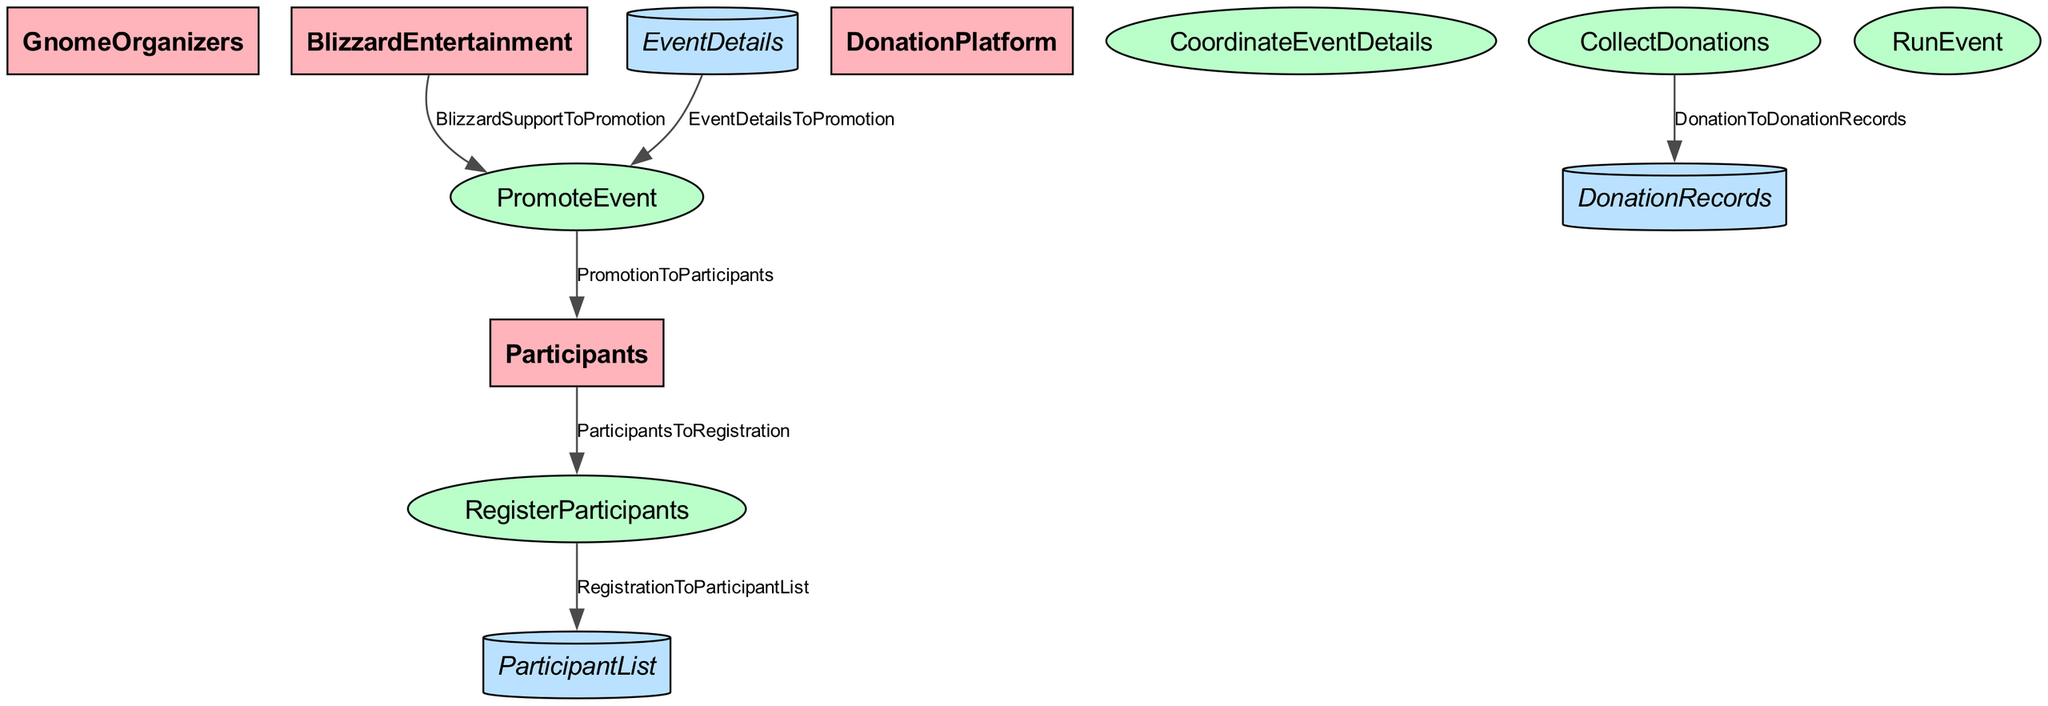What are the entities involved in the Running of the Gnomes event? The diagram includes four entities: GnomeOrganizers, Participants, DonationPlatform, and BlizzardEntertainment.
Answer: GnomeOrganizers, Participants, DonationPlatform, BlizzardEntertainment How many processes are in the Running of the Gnomes organization? The diagram lists five processes: CoordinateEventDetails, PromoteEvent, RegisterParticipants, CollectDonations, and RunEvent. Count each identified process to determine the total.
Answer: 5 What data store keeps track of donations? The diagram indicates that DonationRecords is the data store responsible for tracking donations made through the DonationPlatform.
Answer: DonationRecords Which process collects donations? The diagram shows that the CollectDonations process is responsible for participants donating through the DonationPlatform.
Answer: CollectDonations What flow connects Promotion and Participants? The flow labeled PromotionToParticipants indicates that promotional materials reach participants to encourage joining the event.
Answer: PromotionToParticipants What support does BlizzardEntertainment provide in the event organization? The diagram indicates that BlizzardEntertainment provides support to the PromoteEvent process, which may assist in promoting the event.
Answer: PromoteEvent What happens after participants register? The process RegisterParticipants feeds participant data into the data store ParticipantList, storing the information of registered participants.
Answer: ParticipantList Which process involves the actual event? The diagram specifies that the RunEvent process is where the actual running of the gnomes occurs with participants following the planned route.
Answer: RunEvent How does event detail flow into promotion? The flow labeled EventDetailsToPromotion shows that details about the event are used to create promotional materials for the event.
Answer: EventDetailsToPromotion 